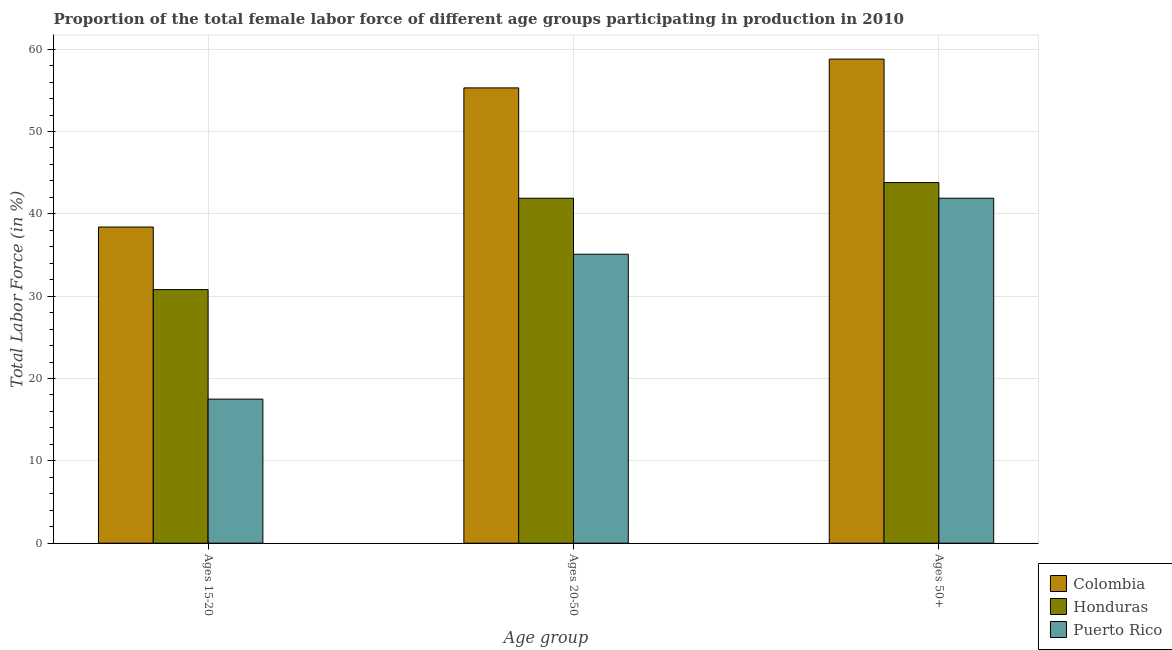How many different coloured bars are there?
Your answer should be compact. 3. How many bars are there on the 1st tick from the right?
Provide a short and direct response. 3. What is the label of the 1st group of bars from the left?
Provide a short and direct response. Ages 15-20. What is the percentage of female labor force above age 50 in Colombia?
Provide a short and direct response. 58.8. Across all countries, what is the maximum percentage of female labor force within the age group 15-20?
Provide a short and direct response. 38.4. In which country was the percentage of female labor force within the age group 20-50 maximum?
Give a very brief answer. Colombia. In which country was the percentage of female labor force within the age group 15-20 minimum?
Your answer should be very brief. Puerto Rico. What is the total percentage of female labor force above age 50 in the graph?
Your answer should be very brief. 144.5. What is the difference between the percentage of female labor force within the age group 20-50 in Puerto Rico and that in Colombia?
Keep it short and to the point. -20.2. What is the difference between the percentage of female labor force within the age group 15-20 in Honduras and the percentage of female labor force within the age group 20-50 in Puerto Rico?
Your response must be concise. -4.3. What is the average percentage of female labor force within the age group 15-20 per country?
Your response must be concise. 28.9. What is the difference between the percentage of female labor force above age 50 and percentage of female labor force within the age group 15-20 in Puerto Rico?
Your answer should be very brief. 24.4. What is the ratio of the percentage of female labor force above age 50 in Colombia to that in Honduras?
Ensure brevity in your answer.  1.34. Is the percentage of female labor force within the age group 15-20 in Colombia less than that in Puerto Rico?
Your answer should be very brief. No. What is the difference between the highest and the second highest percentage of female labor force within the age group 20-50?
Your response must be concise. 13.4. What is the difference between the highest and the lowest percentage of female labor force within the age group 15-20?
Ensure brevity in your answer.  20.9. In how many countries, is the percentage of female labor force within the age group 20-50 greater than the average percentage of female labor force within the age group 20-50 taken over all countries?
Make the answer very short. 1. Is the sum of the percentage of female labor force above age 50 in Colombia and Puerto Rico greater than the maximum percentage of female labor force within the age group 15-20 across all countries?
Make the answer very short. Yes. What does the 1st bar from the right in Ages 20-50 represents?
Your answer should be very brief. Puerto Rico. What is the difference between two consecutive major ticks on the Y-axis?
Make the answer very short. 10. Are the values on the major ticks of Y-axis written in scientific E-notation?
Your answer should be compact. No. Does the graph contain any zero values?
Ensure brevity in your answer.  No. Does the graph contain grids?
Provide a short and direct response. Yes. How many legend labels are there?
Offer a terse response. 3. What is the title of the graph?
Your answer should be very brief. Proportion of the total female labor force of different age groups participating in production in 2010. Does "Serbia" appear as one of the legend labels in the graph?
Ensure brevity in your answer.  No. What is the label or title of the X-axis?
Offer a very short reply. Age group. What is the label or title of the Y-axis?
Make the answer very short. Total Labor Force (in %). What is the Total Labor Force (in %) of Colombia in Ages 15-20?
Provide a short and direct response. 38.4. What is the Total Labor Force (in %) of Honduras in Ages 15-20?
Keep it short and to the point. 30.8. What is the Total Labor Force (in %) in Puerto Rico in Ages 15-20?
Provide a short and direct response. 17.5. What is the Total Labor Force (in %) in Colombia in Ages 20-50?
Offer a terse response. 55.3. What is the Total Labor Force (in %) in Honduras in Ages 20-50?
Your answer should be compact. 41.9. What is the Total Labor Force (in %) in Puerto Rico in Ages 20-50?
Keep it short and to the point. 35.1. What is the Total Labor Force (in %) in Colombia in Ages 50+?
Your answer should be compact. 58.8. What is the Total Labor Force (in %) in Honduras in Ages 50+?
Provide a succinct answer. 43.8. What is the Total Labor Force (in %) in Puerto Rico in Ages 50+?
Your response must be concise. 41.9. Across all Age group, what is the maximum Total Labor Force (in %) of Colombia?
Give a very brief answer. 58.8. Across all Age group, what is the maximum Total Labor Force (in %) of Honduras?
Make the answer very short. 43.8. Across all Age group, what is the maximum Total Labor Force (in %) in Puerto Rico?
Your response must be concise. 41.9. Across all Age group, what is the minimum Total Labor Force (in %) in Colombia?
Give a very brief answer. 38.4. Across all Age group, what is the minimum Total Labor Force (in %) of Honduras?
Provide a succinct answer. 30.8. Across all Age group, what is the minimum Total Labor Force (in %) of Puerto Rico?
Offer a terse response. 17.5. What is the total Total Labor Force (in %) in Colombia in the graph?
Offer a very short reply. 152.5. What is the total Total Labor Force (in %) in Honduras in the graph?
Your response must be concise. 116.5. What is the total Total Labor Force (in %) of Puerto Rico in the graph?
Offer a terse response. 94.5. What is the difference between the Total Labor Force (in %) in Colombia in Ages 15-20 and that in Ages 20-50?
Offer a very short reply. -16.9. What is the difference between the Total Labor Force (in %) in Puerto Rico in Ages 15-20 and that in Ages 20-50?
Your response must be concise. -17.6. What is the difference between the Total Labor Force (in %) of Colombia in Ages 15-20 and that in Ages 50+?
Your response must be concise. -20.4. What is the difference between the Total Labor Force (in %) in Honduras in Ages 15-20 and that in Ages 50+?
Ensure brevity in your answer.  -13. What is the difference between the Total Labor Force (in %) in Puerto Rico in Ages 15-20 and that in Ages 50+?
Offer a very short reply. -24.4. What is the difference between the Total Labor Force (in %) of Colombia in Ages 20-50 and that in Ages 50+?
Give a very brief answer. -3.5. What is the difference between the Total Labor Force (in %) of Honduras in Ages 20-50 and that in Ages 50+?
Provide a short and direct response. -1.9. What is the difference between the Total Labor Force (in %) of Puerto Rico in Ages 20-50 and that in Ages 50+?
Provide a succinct answer. -6.8. What is the difference between the Total Labor Force (in %) of Colombia in Ages 15-20 and the Total Labor Force (in %) of Puerto Rico in Ages 20-50?
Ensure brevity in your answer.  3.3. What is the difference between the Total Labor Force (in %) in Colombia in Ages 15-20 and the Total Labor Force (in %) in Honduras in Ages 50+?
Provide a short and direct response. -5.4. What is the difference between the Total Labor Force (in %) of Honduras in Ages 15-20 and the Total Labor Force (in %) of Puerto Rico in Ages 50+?
Keep it short and to the point. -11.1. What is the difference between the Total Labor Force (in %) in Colombia in Ages 20-50 and the Total Labor Force (in %) in Honduras in Ages 50+?
Your answer should be very brief. 11.5. What is the difference between the Total Labor Force (in %) in Colombia in Ages 20-50 and the Total Labor Force (in %) in Puerto Rico in Ages 50+?
Offer a very short reply. 13.4. What is the difference between the Total Labor Force (in %) in Honduras in Ages 20-50 and the Total Labor Force (in %) in Puerto Rico in Ages 50+?
Your answer should be very brief. 0. What is the average Total Labor Force (in %) of Colombia per Age group?
Make the answer very short. 50.83. What is the average Total Labor Force (in %) of Honduras per Age group?
Keep it short and to the point. 38.83. What is the average Total Labor Force (in %) in Puerto Rico per Age group?
Give a very brief answer. 31.5. What is the difference between the Total Labor Force (in %) in Colombia and Total Labor Force (in %) in Puerto Rico in Ages 15-20?
Provide a succinct answer. 20.9. What is the difference between the Total Labor Force (in %) of Honduras and Total Labor Force (in %) of Puerto Rico in Ages 15-20?
Give a very brief answer. 13.3. What is the difference between the Total Labor Force (in %) of Colombia and Total Labor Force (in %) of Honduras in Ages 20-50?
Your response must be concise. 13.4. What is the difference between the Total Labor Force (in %) of Colombia and Total Labor Force (in %) of Puerto Rico in Ages 20-50?
Make the answer very short. 20.2. What is the difference between the Total Labor Force (in %) in Colombia and Total Labor Force (in %) in Honduras in Ages 50+?
Your answer should be compact. 15. What is the difference between the Total Labor Force (in %) of Colombia and Total Labor Force (in %) of Puerto Rico in Ages 50+?
Make the answer very short. 16.9. What is the ratio of the Total Labor Force (in %) in Colombia in Ages 15-20 to that in Ages 20-50?
Ensure brevity in your answer.  0.69. What is the ratio of the Total Labor Force (in %) of Honduras in Ages 15-20 to that in Ages 20-50?
Offer a very short reply. 0.74. What is the ratio of the Total Labor Force (in %) in Puerto Rico in Ages 15-20 to that in Ages 20-50?
Give a very brief answer. 0.5. What is the ratio of the Total Labor Force (in %) of Colombia in Ages 15-20 to that in Ages 50+?
Offer a very short reply. 0.65. What is the ratio of the Total Labor Force (in %) in Honduras in Ages 15-20 to that in Ages 50+?
Provide a short and direct response. 0.7. What is the ratio of the Total Labor Force (in %) in Puerto Rico in Ages 15-20 to that in Ages 50+?
Offer a terse response. 0.42. What is the ratio of the Total Labor Force (in %) of Colombia in Ages 20-50 to that in Ages 50+?
Give a very brief answer. 0.94. What is the ratio of the Total Labor Force (in %) in Honduras in Ages 20-50 to that in Ages 50+?
Ensure brevity in your answer.  0.96. What is the ratio of the Total Labor Force (in %) of Puerto Rico in Ages 20-50 to that in Ages 50+?
Give a very brief answer. 0.84. What is the difference between the highest and the second highest Total Labor Force (in %) in Honduras?
Your answer should be very brief. 1.9. What is the difference between the highest and the second highest Total Labor Force (in %) in Puerto Rico?
Offer a terse response. 6.8. What is the difference between the highest and the lowest Total Labor Force (in %) in Colombia?
Provide a succinct answer. 20.4. What is the difference between the highest and the lowest Total Labor Force (in %) in Honduras?
Offer a terse response. 13. What is the difference between the highest and the lowest Total Labor Force (in %) of Puerto Rico?
Your answer should be very brief. 24.4. 